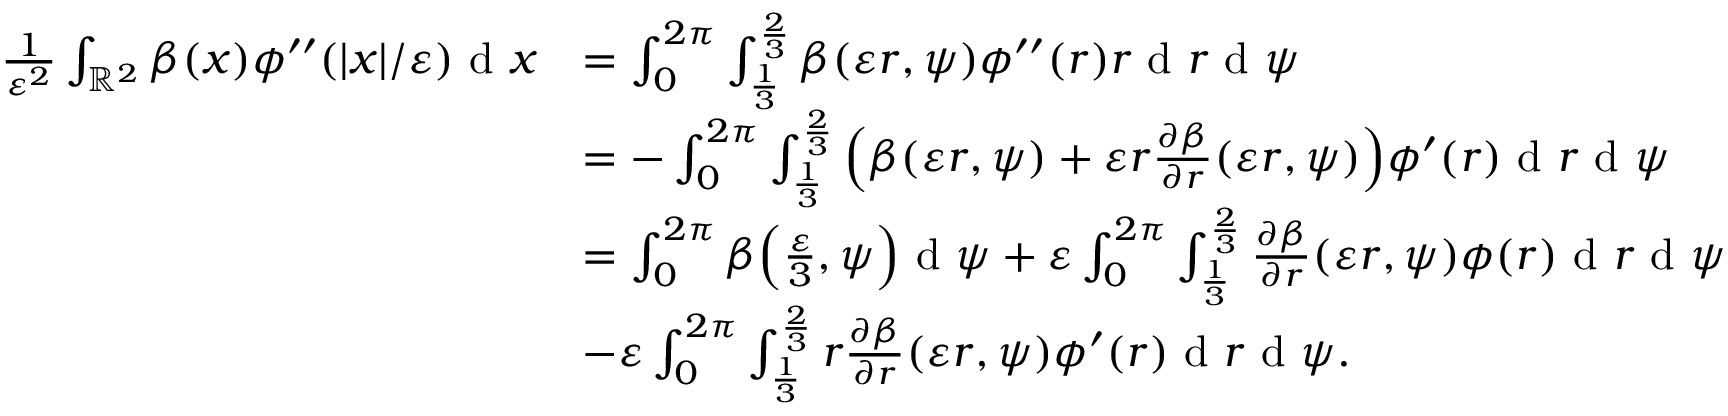<formula> <loc_0><loc_0><loc_500><loc_500>\begin{array} { r l } { \frac { 1 } { \varepsilon ^ { 2 } } \int _ { \mathbb { R } ^ { 2 } } \beta ( x ) \phi ^ { \prime \prime } ( | x | / \varepsilon ) d x } & { = \int _ { 0 } ^ { 2 \pi } \int _ { \frac { 1 } { 3 } } ^ { \frac { 2 } { 3 } } \beta ( \varepsilon r , \psi ) \phi ^ { \prime \prime } ( r ) r d r d \psi } \\ & { = - \int _ { 0 } ^ { 2 \pi } \int _ { \frac { 1 } { 3 } } ^ { \frac { 2 } { 3 } } \left ( \beta ( \varepsilon r , \psi ) + \varepsilon r \frac { \partial \beta } { \partial r } ( \varepsilon r , \psi ) \right ) \phi ^ { \prime } ( r ) d r d \psi } \\ & { = \int _ { 0 } ^ { 2 \pi } \beta \left ( \frac { \varepsilon } { 3 } , \psi \right ) d \psi + \varepsilon \int _ { 0 } ^ { 2 \pi } \int _ { \frac { 1 } { 3 } } ^ { \frac { 2 } { 3 } } \frac { \partial \beta } { \partial r } ( \varepsilon r , \psi ) \phi ( r ) d r d \psi } \\ & { - \varepsilon \int _ { 0 } ^ { 2 \pi } \int _ { \frac { 1 } { 3 } } ^ { \frac { 2 } { 3 } } r \frac { \partial \beta } { \partial r } ( \varepsilon r , \psi ) \phi ^ { \prime } ( r ) d r d \psi . } \end{array}</formula> 